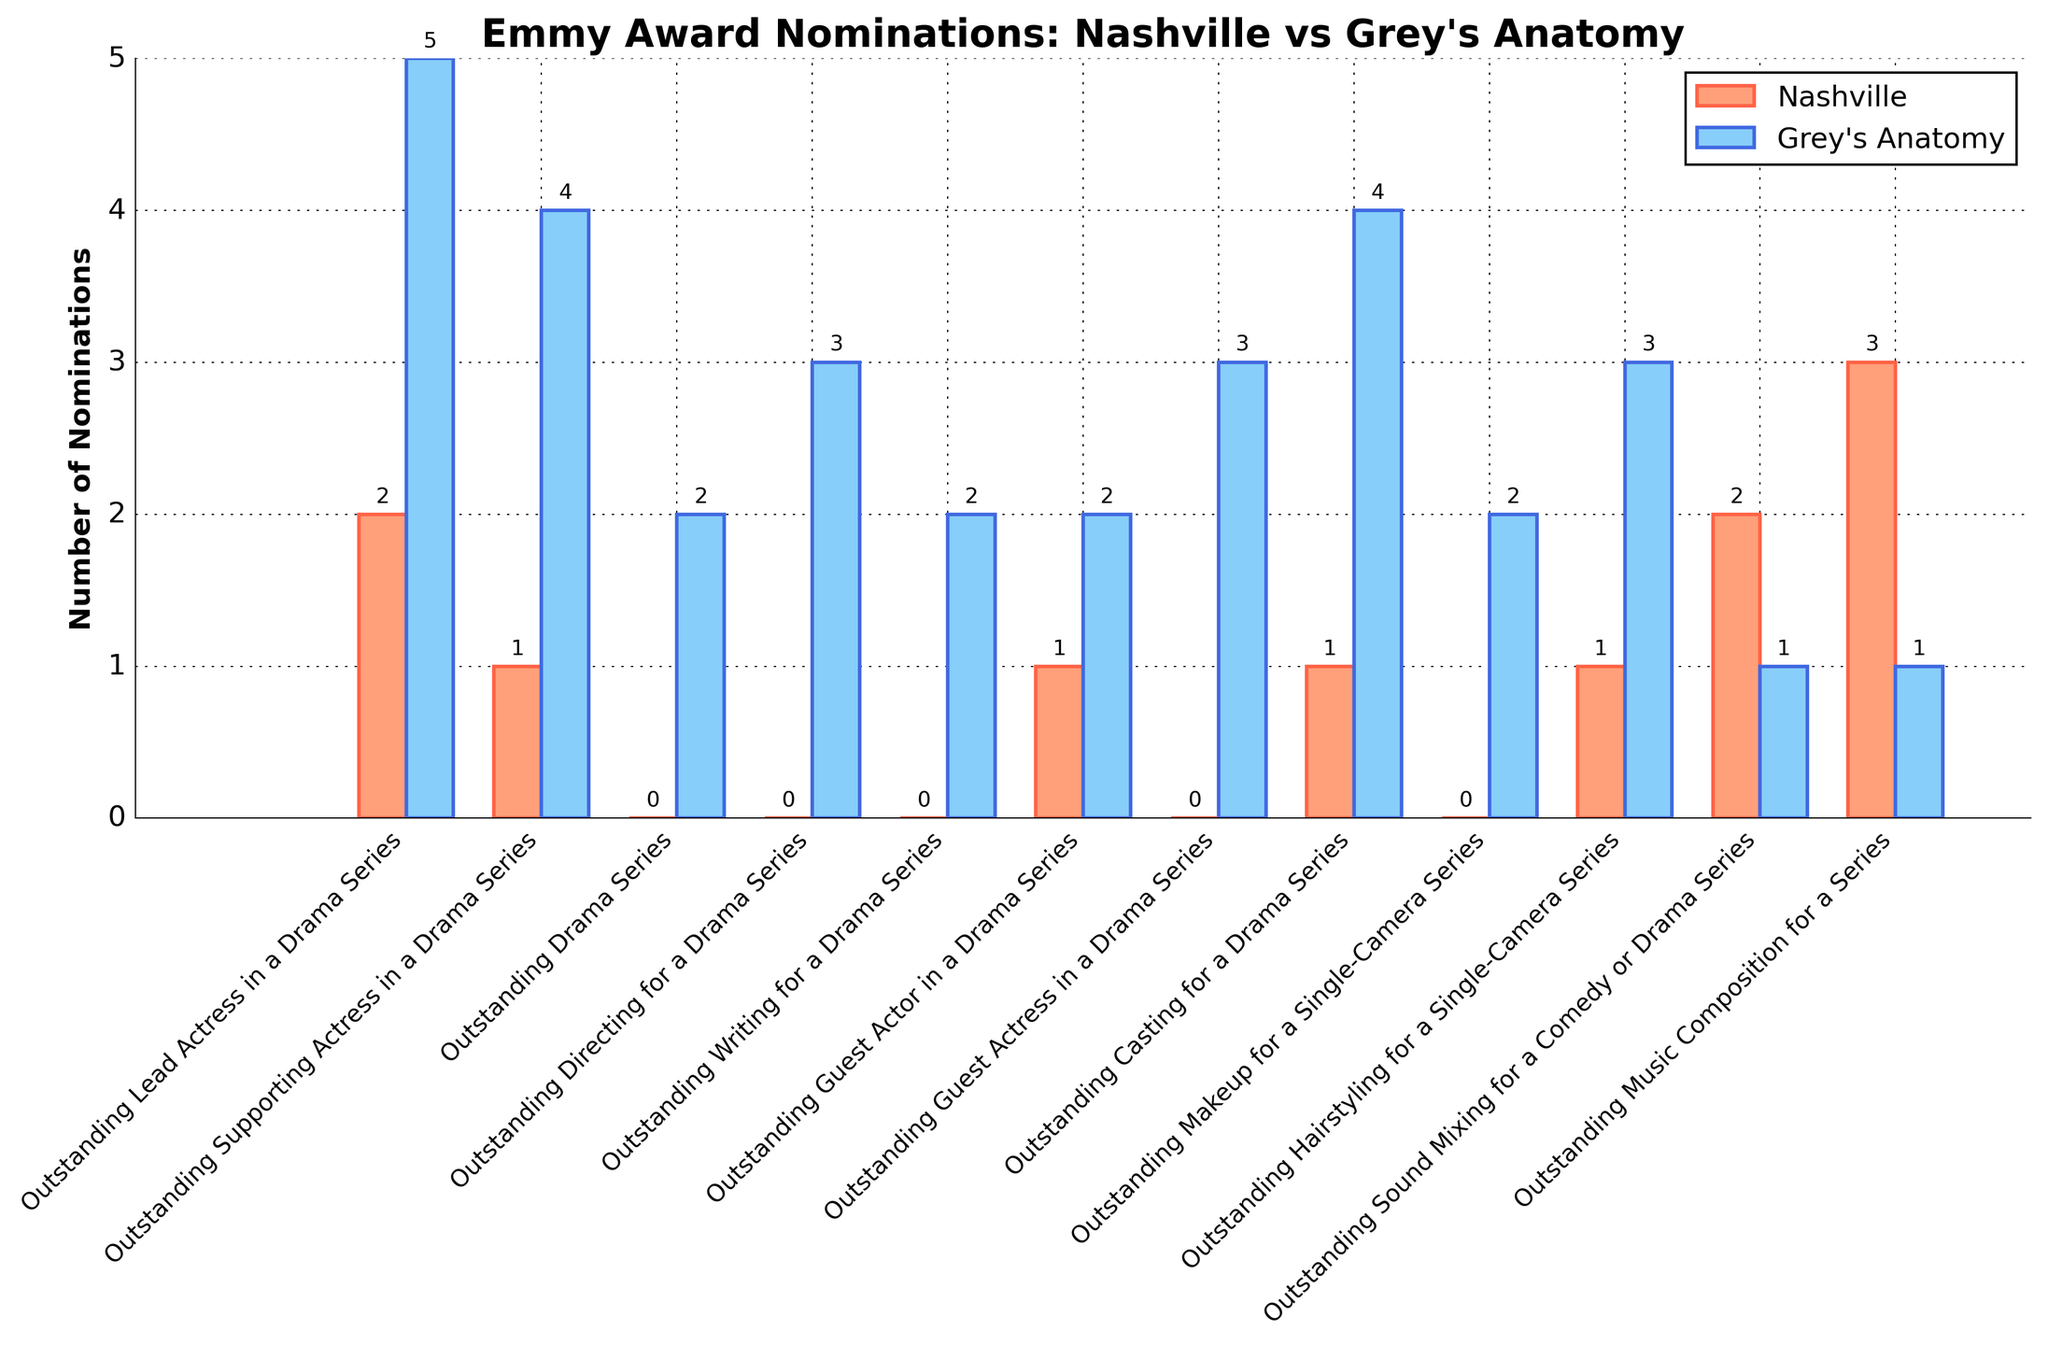what is the total number of nominations for Nashville? Sum the Nashville nominations across all categories: 2+1+0+0+0+1+0+1+0+1+2+3 = 11
Answer: 11 Which show has more nominations in the category "Outstanding Drama Series"? Look at the bar heights for the "Outstanding Drama Series" category and compare them: Nashville has 0 and Grey's Anatomy has 2.
Answer: Grey's Anatomy In which category does Nashville have the highest number of nominations? Compare the bar heights for all categories under Nashville, the "Outstanding Music Composition for a Series" category has the highest bar with 3 nominations.
Answer: Outstanding Music Composition for a Series How many more nominations does Grey's Anatomy have in "Outstanding Lead Actress in a Drama Series" compared to Nashville? Subtract the nominations in "Outstanding Lead Actress in a Drama Series" for Nashville (2) from Grey's Anatomy (5): 5 - 2 = 3
Answer: 3 What is the difference in nominations between the two shows in the "Outstanding Directing for a Drama Series" category? Compare the bar heights in "Outstanding Directing for a Drama Series": Nashville has 0 and Grey's Anatomy has 3; 3 - 0 = 3
Answer: 3 Which show has fewer nominations in the "Outstanding Sound Mixing for a Comedy or Drama Series" category? Compare the nominations in the category "Outstanding Sound Mixing for a Comedy or Drama Series": Nashville has 2, and Grey's Anatomy has 1.
Answer: Grey's Anatomy Which show has more nominations in the "Outstanding Guest Actress in a Drama Series" category, and by how much? Compare the category "Outstanding Guest Actress in a Drama Series" visually: Nashville has 0, Grey's Anatomy has 3. The difference is 3 - 0 = 3.
Answer: Grey's Anatomy by 3 How many categories does Grey's Anatomy lead in nominations compared to Nashville? Count the categories where Grey's Anatomy has a higher bar height than Nashville: "Outstanding Lead Actress in a Drama Series," "Outstanding Supporting Actress in a Drama Series," "Outstanding Drama Series," "Outstanding Directing for a Drama Series," "Outstanding Writing for a Drama Series," "Outstanding Guest Actress in a Drama Series," "Outstanding Casting for a Drama Series," and "Outstanding Hairstyling for a Single-Camera Series"—a total of 8 categories.
Answer: 8 How many total nominations do both shows have combined in the category "Outstanding Lead Actress in a Drama Series"? Add the nominations of both shows in the "Outstanding Lead Actress in a Drama Series" category: Nashville has 2, Grey's Anatomy has 5. 2 + 5 = 7
Answer: 7 